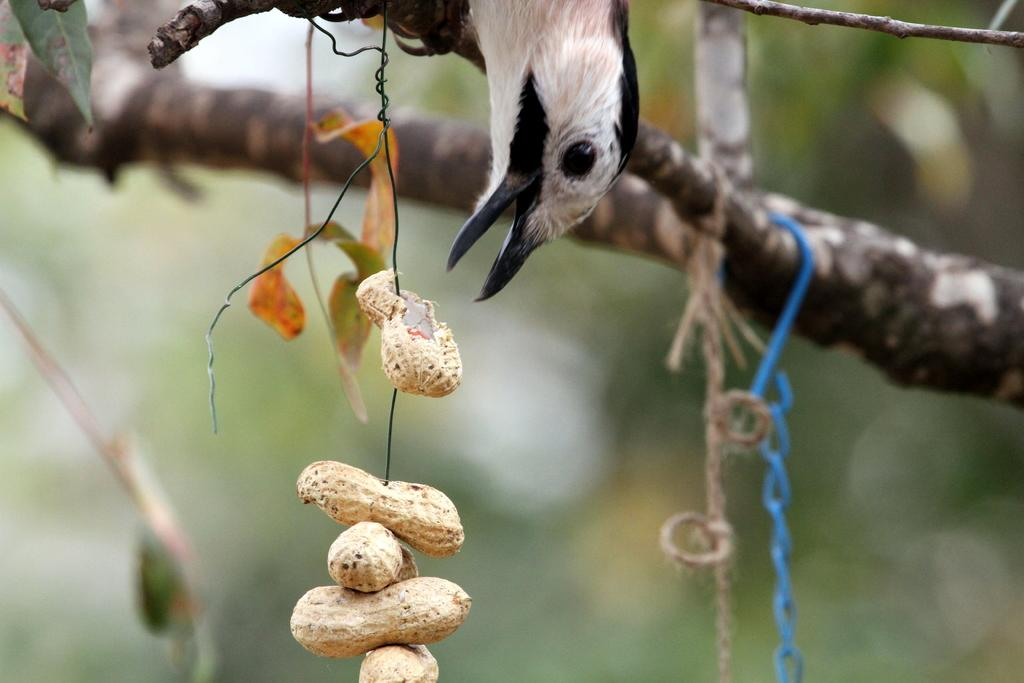What animal is present in the image? There is a bird in the image. What is the bird attempting to do? The bird is trying to eat a peanut. How is the peanut positioned in the image? The peanut is hanged. What can be seen in the background of the image? There is a tree branch in the image. What objects are used to hang the peanut? There is a wire and a rope in the image. How many men are on the team in the image? There are no men or teams present in the image; it features a bird trying to eat a hanged peanut. What type of plane can be seen flying in the image? There is no plane visible in the image. 